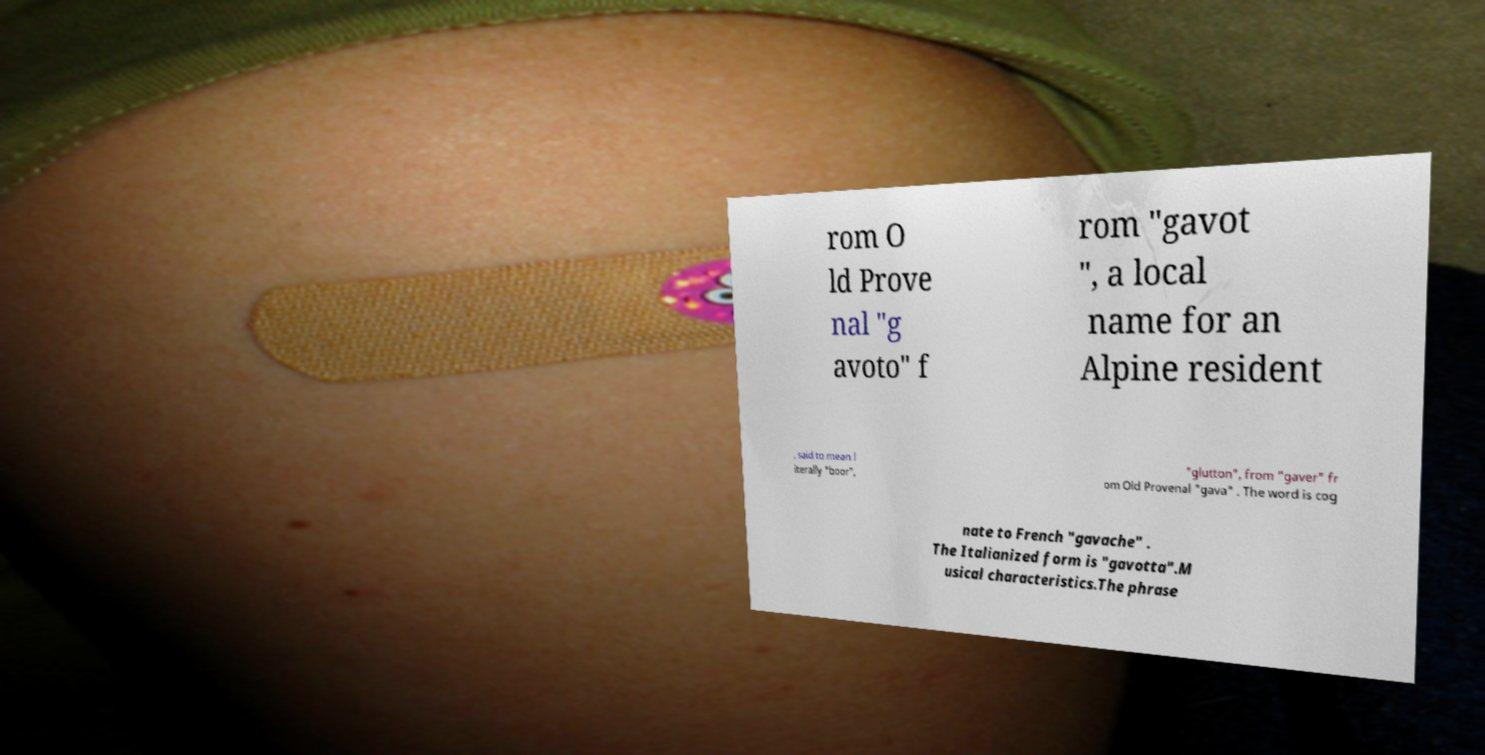Can you read and provide the text displayed in the image?This photo seems to have some interesting text. Can you extract and type it out for me? rom O ld Prove nal "g avoto" f rom "gavot ", a local name for an Alpine resident , said to mean l iterally "boor", "glutton", from "gaver" fr om Old Provenal "gava" . The word is cog nate to French "gavache" . The Italianized form is "gavotta".M usical characteristics.The phrase 